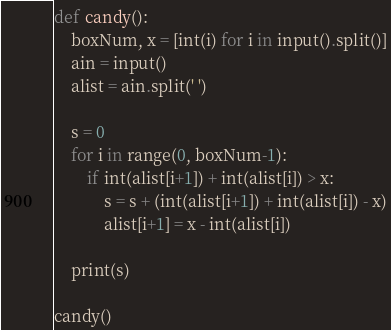<code> <loc_0><loc_0><loc_500><loc_500><_Python_>def candy():
    boxNum, x = [int(i) for i in input().split()]
    ain = input()
    alist = ain.split(' ')

    s = 0
    for i in range(0, boxNum-1):
        if int(alist[i+1]) + int(alist[i]) > x:
            s = s + (int(alist[i+1]) + int(alist[i]) - x)
            alist[i+1] = x - int(alist[i])
        
    print(s)
    
candy()</code> 